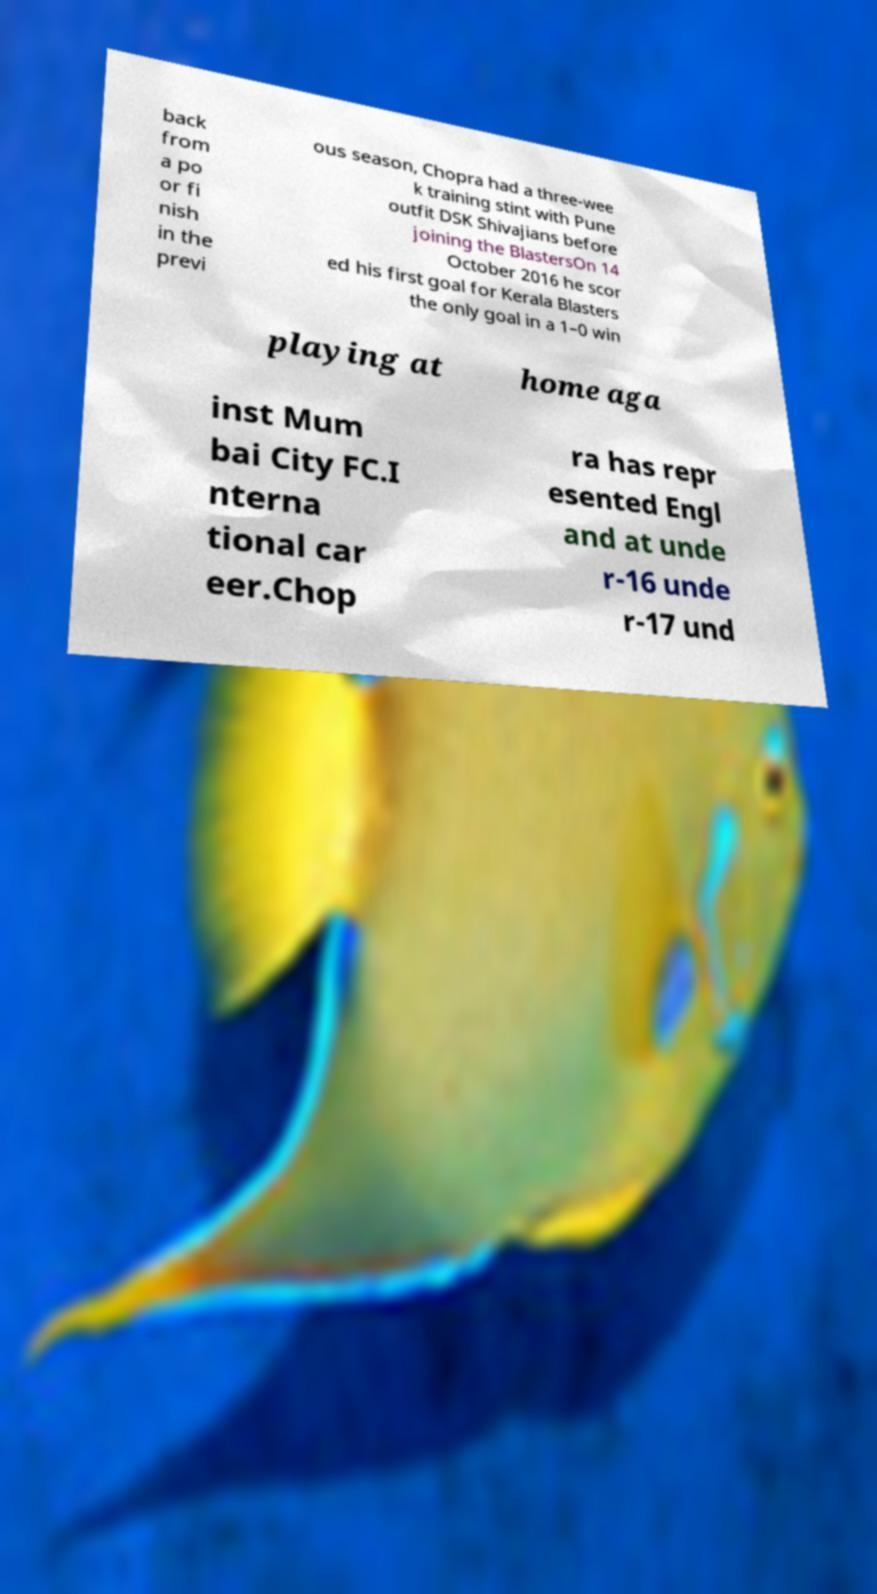I need the written content from this picture converted into text. Can you do that? back from a po or fi nish in the previ ous season, Chopra had a three-wee k training stint with Pune outfit DSK Shivajians before joining the BlastersOn 14 October 2016 he scor ed his first goal for Kerala Blasters the only goal in a 1–0 win playing at home aga inst Mum bai City FC.I nterna tional car eer.Chop ra has repr esented Engl and at unde r-16 unde r-17 und 